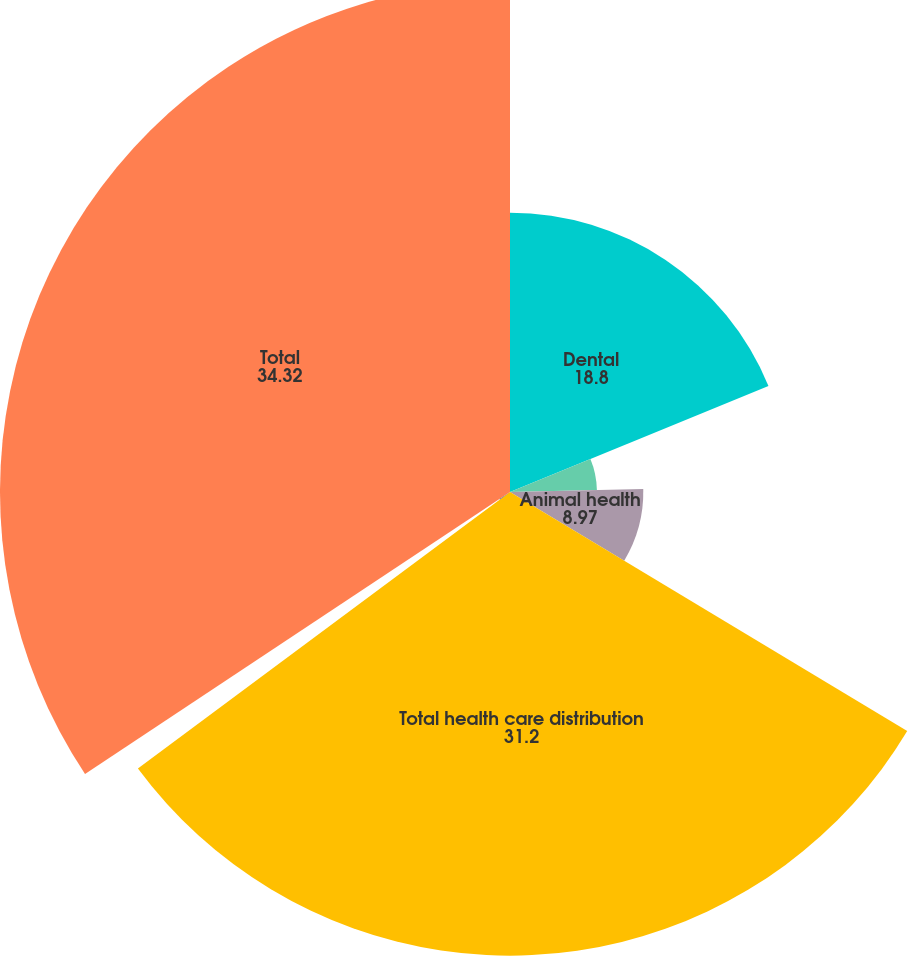<chart> <loc_0><loc_0><loc_500><loc_500><pie_chart><fcel>Dental<fcel>Medical<fcel>Animal health<fcel>Total health care distribution<fcel>Technology and value-added<fcel>Total<nl><fcel>18.8%<fcel>5.85%<fcel>8.97%<fcel>31.2%<fcel>0.85%<fcel>34.32%<nl></chart> 